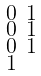<formula> <loc_0><loc_0><loc_500><loc_500>\begin{smallmatrix} 0 & 1 \\ 0 & 1 \\ 0 & 1 \\ 1 \end{smallmatrix}</formula> 